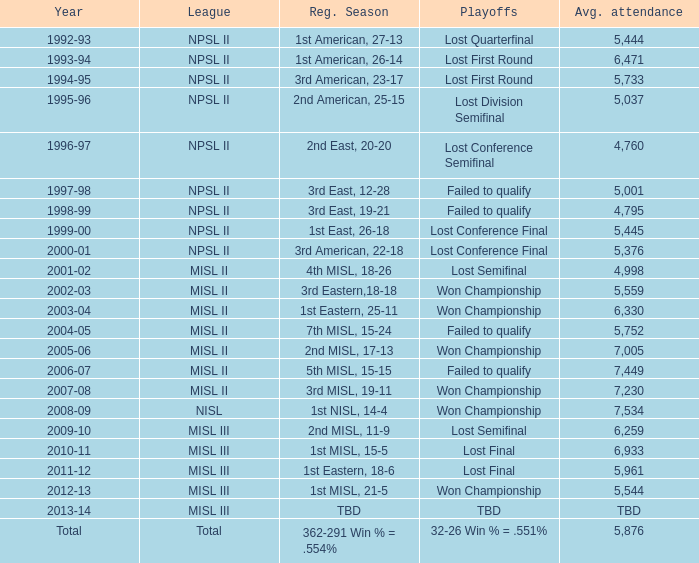Can you parse all the data within this table? {'header': ['Year', 'League', 'Reg. Season', 'Playoffs', 'Avg. attendance'], 'rows': [['1992-93', 'NPSL II', '1st American, 27-13', 'Lost Quarterfinal', '5,444'], ['1993-94', 'NPSL II', '1st American, 26-14', 'Lost First Round', '6,471'], ['1994-95', 'NPSL II', '3rd American, 23-17', 'Lost First Round', '5,733'], ['1995-96', 'NPSL II', '2nd American, 25-15', 'Lost Division Semifinal', '5,037'], ['1996-97', 'NPSL II', '2nd East, 20-20', 'Lost Conference Semifinal', '4,760'], ['1997-98', 'NPSL II', '3rd East, 12-28', 'Failed to qualify', '5,001'], ['1998-99', 'NPSL II', '3rd East, 19-21', 'Failed to qualify', '4,795'], ['1999-00', 'NPSL II', '1st East, 26-18', 'Lost Conference Final', '5,445'], ['2000-01', 'NPSL II', '3rd American, 22-18', 'Lost Conference Final', '5,376'], ['2001-02', 'MISL II', '4th MISL, 18-26', 'Lost Semifinal', '4,998'], ['2002-03', 'MISL II', '3rd Eastern,18-18', 'Won Championship', '5,559'], ['2003-04', 'MISL II', '1st Eastern, 25-11', 'Won Championship', '6,330'], ['2004-05', 'MISL II', '7th MISL, 15-24', 'Failed to qualify', '5,752'], ['2005-06', 'MISL II', '2nd MISL, 17-13', 'Won Championship', '7,005'], ['2006-07', 'MISL II', '5th MISL, 15-15', 'Failed to qualify', '7,449'], ['2007-08', 'MISL II', '3rd MISL, 19-11', 'Won Championship', '7,230'], ['2008-09', 'NISL', '1st NISL, 14-4', 'Won Championship', '7,534'], ['2009-10', 'MISL III', '2nd MISL, 11-9', 'Lost Semifinal', '6,259'], ['2010-11', 'MISL III', '1st MISL, 15-5', 'Lost Final', '6,933'], ['2011-12', 'MISL III', '1st Eastern, 18-6', 'Lost Final', '5,961'], ['2012-13', 'MISL III', '1st MISL, 21-5', 'Won Championship', '5,544'], ['2013-14', 'MISL III', 'TBD', 'TBD', 'TBD'], ['Total', 'Total', '362-291 Win % = .554%', '32-26 Win % = .551%', '5,876']]} In 2010-11, what was the League name? MISL III. 